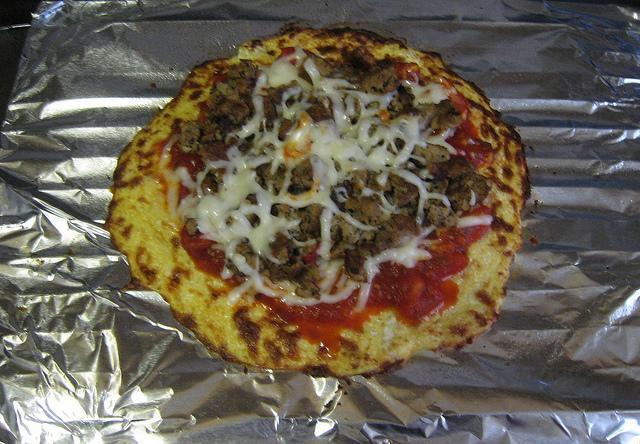How many people are wearing blue shirts?
Give a very brief answer. 0. 